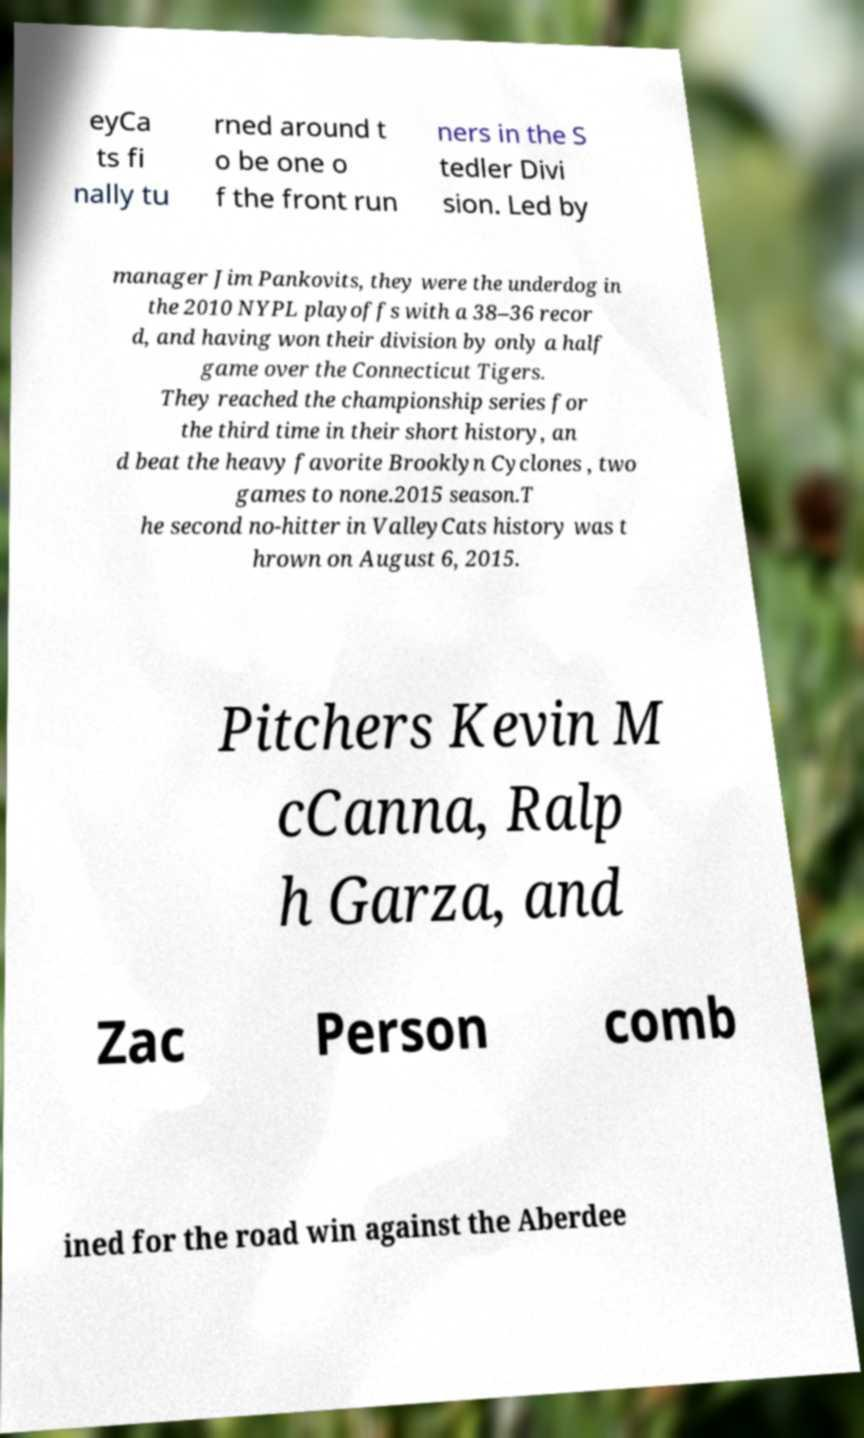What messages or text are displayed in this image? I need them in a readable, typed format. eyCa ts fi nally tu rned around t o be one o f the front run ners in the S tedler Divi sion. Led by manager Jim Pankovits, they were the underdog in the 2010 NYPL playoffs with a 38–36 recor d, and having won their division by only a half game over the Connecticut Tigers. They reached the championship series for the third time in their short history, an d beat the heavy favorite Brooklyn Cyclones , two games to none.2015 season.T he second no-hitter in ValleyCats history was t hrown on August 6, 2015. Pitchers Kevin M cCanna, Ralp h Garza, and Zac Person comb ined for the road win against the Aberdee 